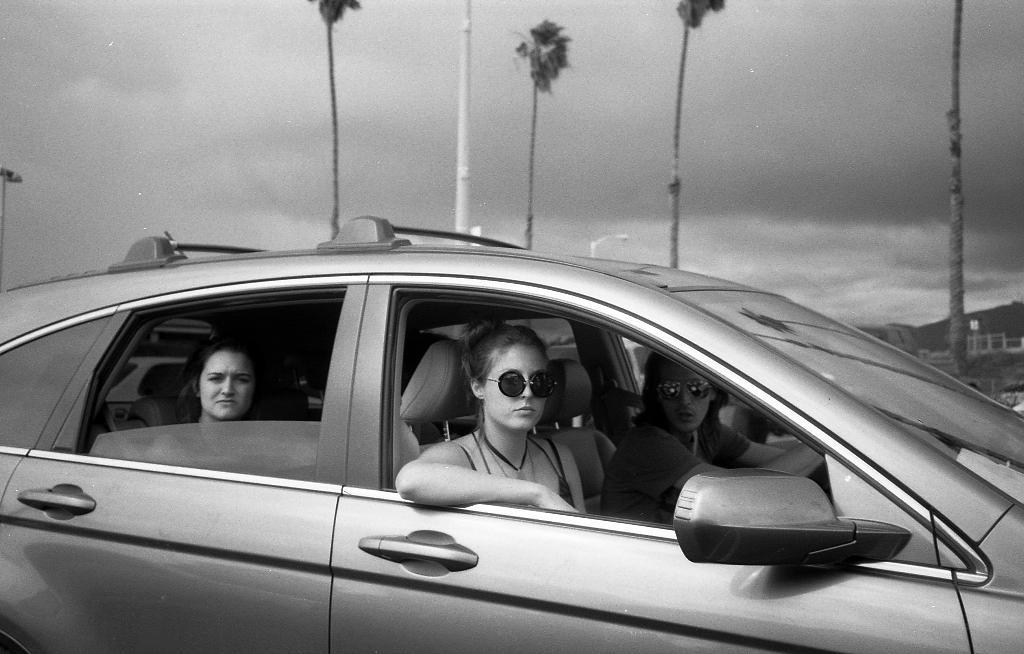How many people are in the image? There are three people in the image. What are the people doing in the image? The people are sitting in a car. What can be seen in the background of the image? There is a sky and trees visible in the background of the image. What type of notebook is the person in the middle holding in the image? There is no notebook present in the image; the people are sitting in a car with no visible objects in their hands. 